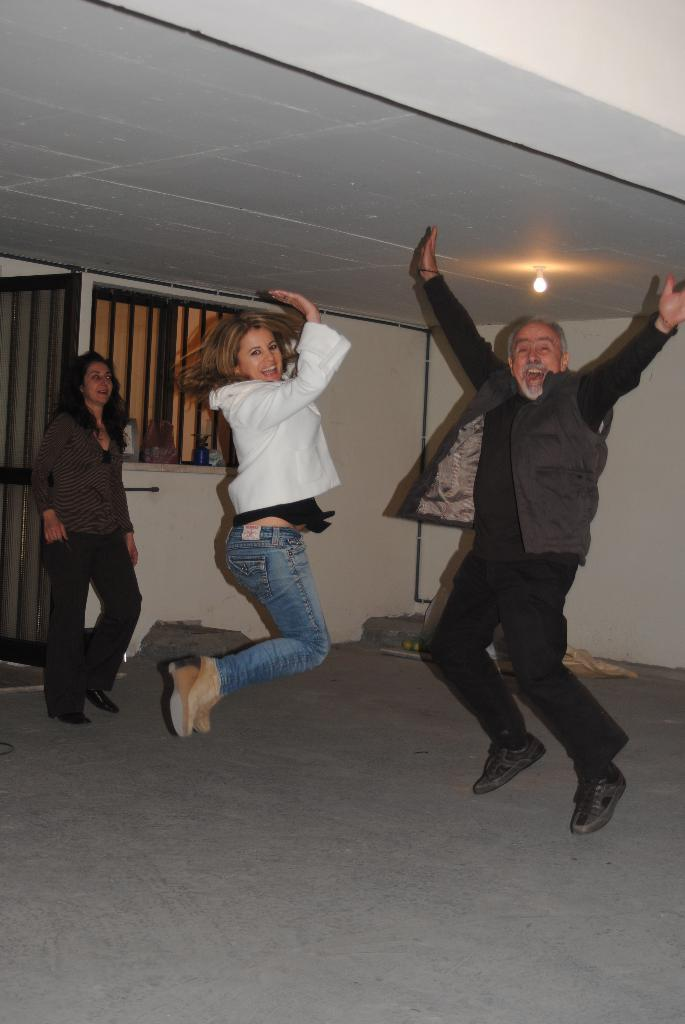What is happening with the people in the image? There are people standing in the image, and a man and a woman are touching the roof. What architectural features can be seen in the image? There is a door and a window in the image. What is the source of light in the image? There is a light in the image. How does the thumb provide comfort to the people in the image? There is no thumb present in the image, so it cannot provide comfort to the people. 